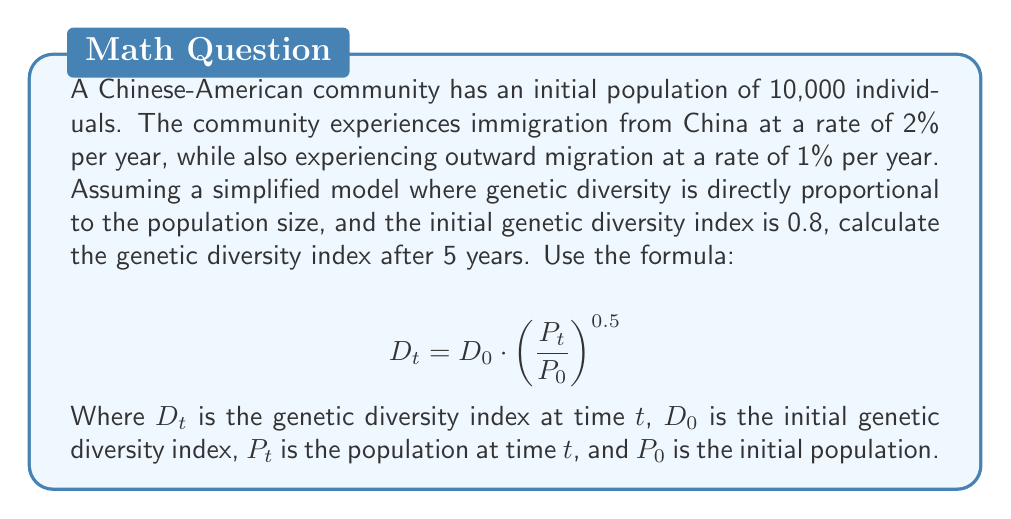What is the answer to this math problem? To solve this problem, we need to follow these steps:

1. Calculate the population growth rate:
   Net growth rate = Immigration rate - Outward migration rate
   $$ r = 0.02 - 0.01 = 0.01 = 1\% $$

2. Calculate the population after 5 years:
   $$ P_t = P_0 \cdot (1 + r)^t $$
   $$ P_5 = 10,000 \cdot (1 + 0.01)^5 $$
   $$ P_5 = 10,000 \cdot (1.01)^5 $$
   $$ P_5 = 10,000 \cdot 1.0510100501 $$
   $$ P_5 = 10,510.10 \approx 10,510 $$

3. Apply the genetic diversity formula:
   $$ D_5 = D_0 \cdot \left(\frac{P_5}{P_0}\right)^{0.5} $$
   $$ D_5 = 0.8 \cdot \left(\frac{10,510}{10,000}\right)^{0.5} $$
   $$ D_5 = 0.8 \cdot (1.051)^{0.5} $$
   $$ D_5 = 0.8 \cdot 1.0251836 $$
   $$ D_5 = 0.82014688 $$

Therefore, the genetic diversity index after 5 years is approximately 0.8201.
Answer: 0.8201 